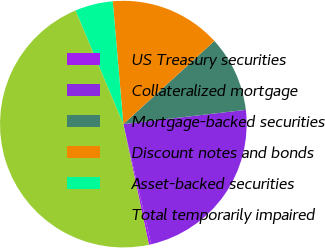<chart> <loc_0><loc_0><loc_500><loc_500><pie_chart><fcel>US Treasury securities<fcel>Collateralized mortgage<fcel>Mortgage-backed securities<fcel>Discount notes and bonds<fcel>Asset-backed securities<fcel>Total temporarily impaired<nl><fcel>0.31%<fcel>23.21%<fcel>9.93%<fcel>14.59%<fcel>4.98%<fcel>46.98%<nl></chart> 